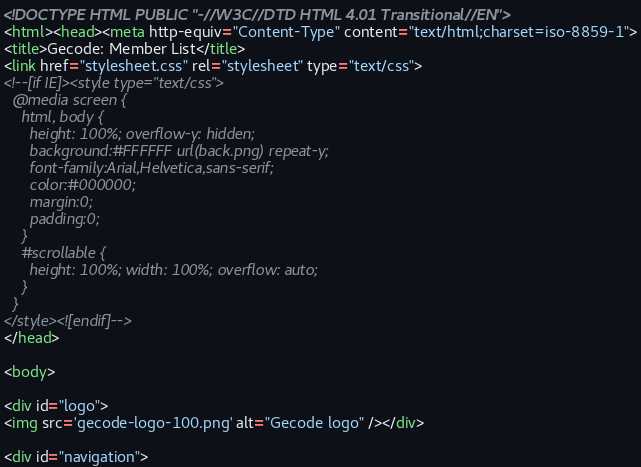<code> <loc_0><loc_0><loc_500><loc_500><_HTML_><!DOCTYPE HTML PUBLIC "-//W3C//DTD HTML 4.01 Transitional//EN">
<html><head><meta http-equiv="Content-Type" content="text/html;charset=iso-8859-1">
<title>Gecode: Member List</title>
<link href="stylesheet.css" rel="stylesheet" type="text/css">
<!--[if IE]><style type="text/css">
  @media screen {
    html, body {
      height: 100%; overflow-y: hidden;
      background:#FFFFFF url(back.png) repeat-y;
      font-family:Arial,Helvetica,sans-serif;
      color:#000000;
      margin:0;
      padding:0;
    }
    #scrollable {
      height: 100%; width: 100%; overflow: auto;
    }
  }
</style><![endif]-->
</head>

<body>

<div id="logo">
<img src='gecode-logo-100.png' alt="Gecode logo" /></div>

<div id="navigation"></code> 